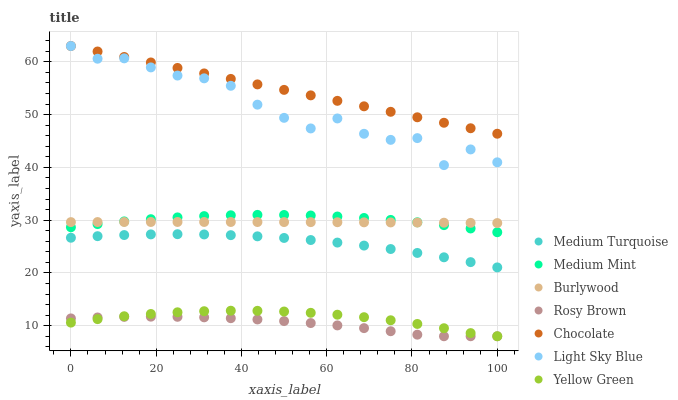Does Rosy Brown have the minimum area under the curve?
Answer yes or no. Yes. Does Chocolate have the maximum area under the curve?
Answer yes or no. Yes. Does Yellow Green have the minimum area under the curve?
Answer yes or no. No. Does Yellow Green have the maximum area under the curve?
Answer yes or no. No. Is Chocolate the smoothest?
Answer yes or no. Yes. Is Light Sky Blue the roughest?
Answer yes or no. Yes. Is Yellow Green the smoothest?
Answer yes or no. No. Is Yellow Green the roughest?
Answer yes or no. No. Does Yellow Green have the lowest value?
Answer yes or no. Yes. Does Burlywood have the lowest value?
Answer yes or no. No. Does Light Sky Blue have the highest value?
Answer yes or no. Yes. Does Yellow Green have the highest value?
Answer yes or no. No. Is Yellow Green less than Burlywood?
Answer yes or no. Yes. Is Light Sky Blue greater than Yellow Green?
Answer yes or no. Yes. Does Medium Mint intersect Burlywood?
Answer yes or no. Yes. Is Medium Mint less than Burlywood?
Answer yes or no. No. Is Medium Mint greater than Burlywood?
Answer yes or no. No. Does Yellow Green intersect Burlywood?
Answer yes or no. No. 